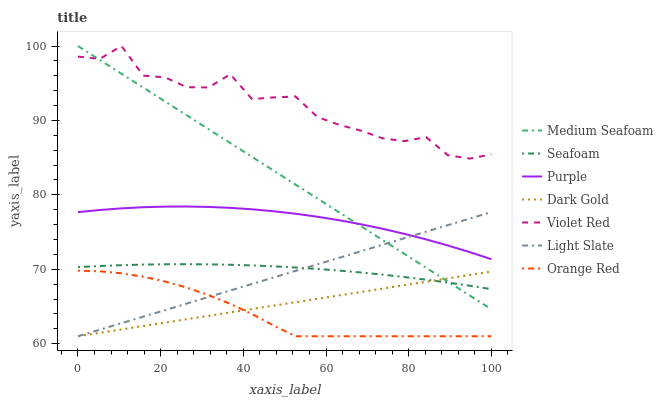Does Orange Red have the minimum area under the curve?
Answer yes or no. Yes. Does Violet Red have the maximum area under the curve?
Answer yes or no. Yes. Does Dark Gold have the minimum area under the curve?
Answer yes or no. No. Does Dark Gold have the maximum area under the curve?
Answer yes or no. No. Is Medium Seafoam the smoothest?
Answer yes or no. Yes. Is Violet Red the roughest?
Answer yes or no. Yes. Is Dark Gold the smoothest?
Answer yes or no. No. Is Dark Gold the roughest?
Answer yes or no. No. Does Dark Gold have the lowest value?
Answer yes or no. Yes. Does Purple have the lowest value?
Answer yes or no. No. Does Medium Seafoam have the highest value?
Answer yes or no. Yes. Does Purple have the highest value?
Answer yes or no. No. Is Seafoam less than Purple?
Answer yes or no. Yes. Is Purple greater than Orange Red?
Answer yes or no. Yes. Does Light Slate intersect Purple?
Answer yes or no. Yes. Is Light Slate less than Purple?
Answer yes or no. No. Is Light Slate greater than Purple?
Answer yes or no. No. Does Seafoam intersect Purple?
Answer yes or no. No. 